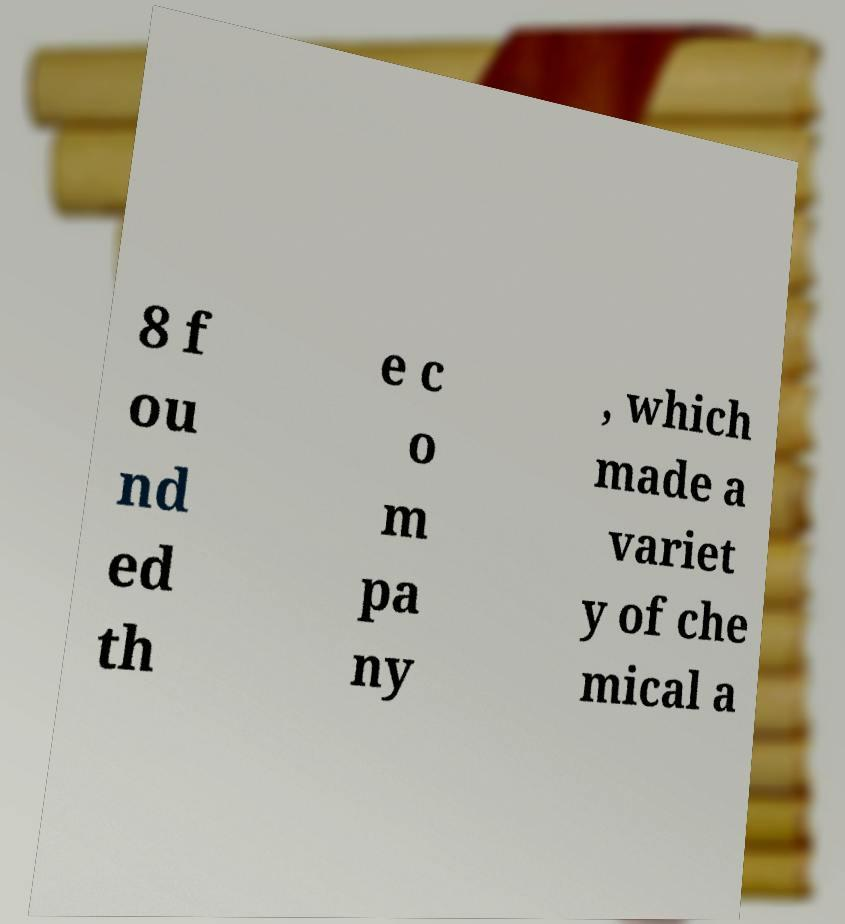I need the written content from this picture converted into text. Can you do that? 8 f ou nd ed th e c o m pa ny , which made a variet y of che mical a 